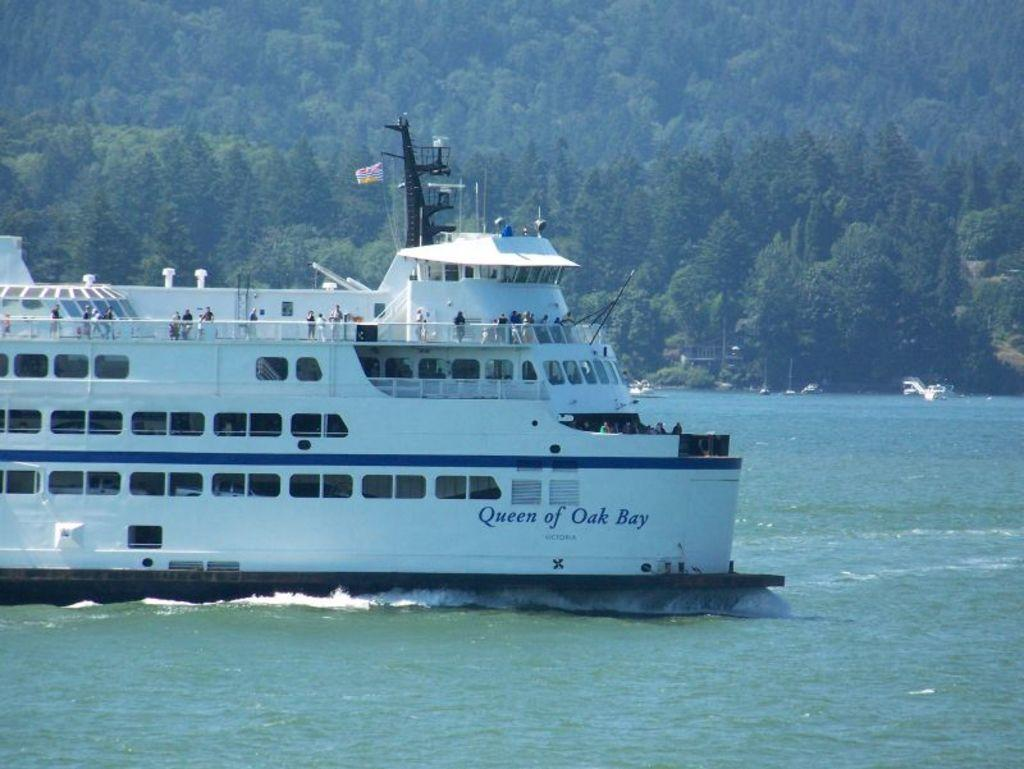What is the main subject of the image? The main subject of the image is a ship. Where is the ship located in the image? The ship is on the surface of the water. What can be seen in the background of the image? There are trees in the background of the image. What month is it in the image? The month is not mentioned or depicted in the image, so it cannot be determined. How many balls are visible in the image? There are no balls present in the image. 